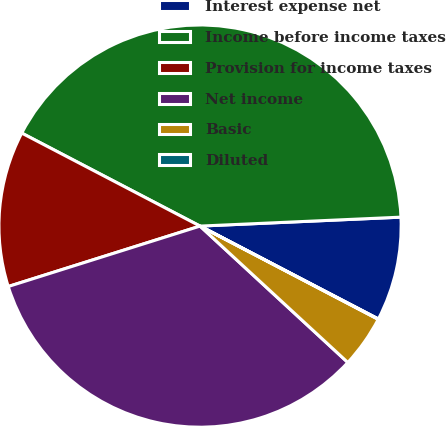Convert chart. <chart><loc_0><loc_0><loc_500><loc_500><pie_chart><fcel>Interest expense net<fcel>Income before income taxes<fcel>Provision for income taxes<fcel>Net income<fcel>Basic<fcel>Diluted<nl><fcel>8.35%<fcel>41.64%<fcel>12.51%<fcel>33.28%<fcel>4.19%<fcel>0.03%<nl></chart> 